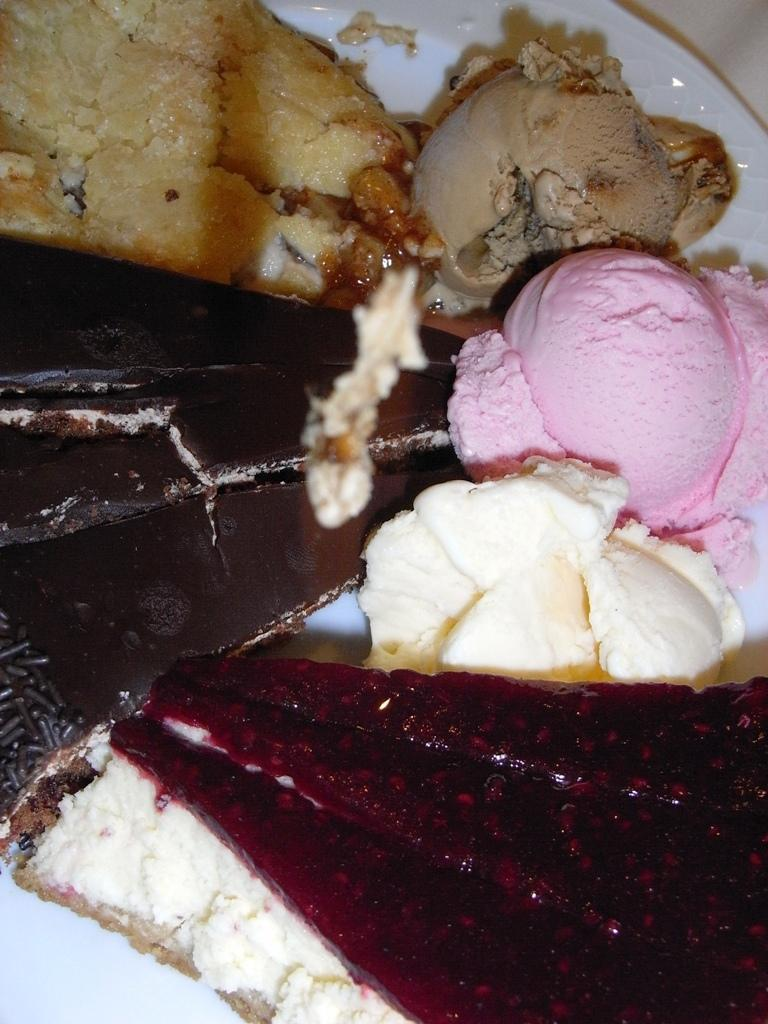What is located in the center of the image? There are food items in the center of the image. How are the food items arranged or presented? The food items are in a plate. What type of brush is being used to paint the food items in the image? There is no brush or painting activity present in the image; it features food items in a plate. 